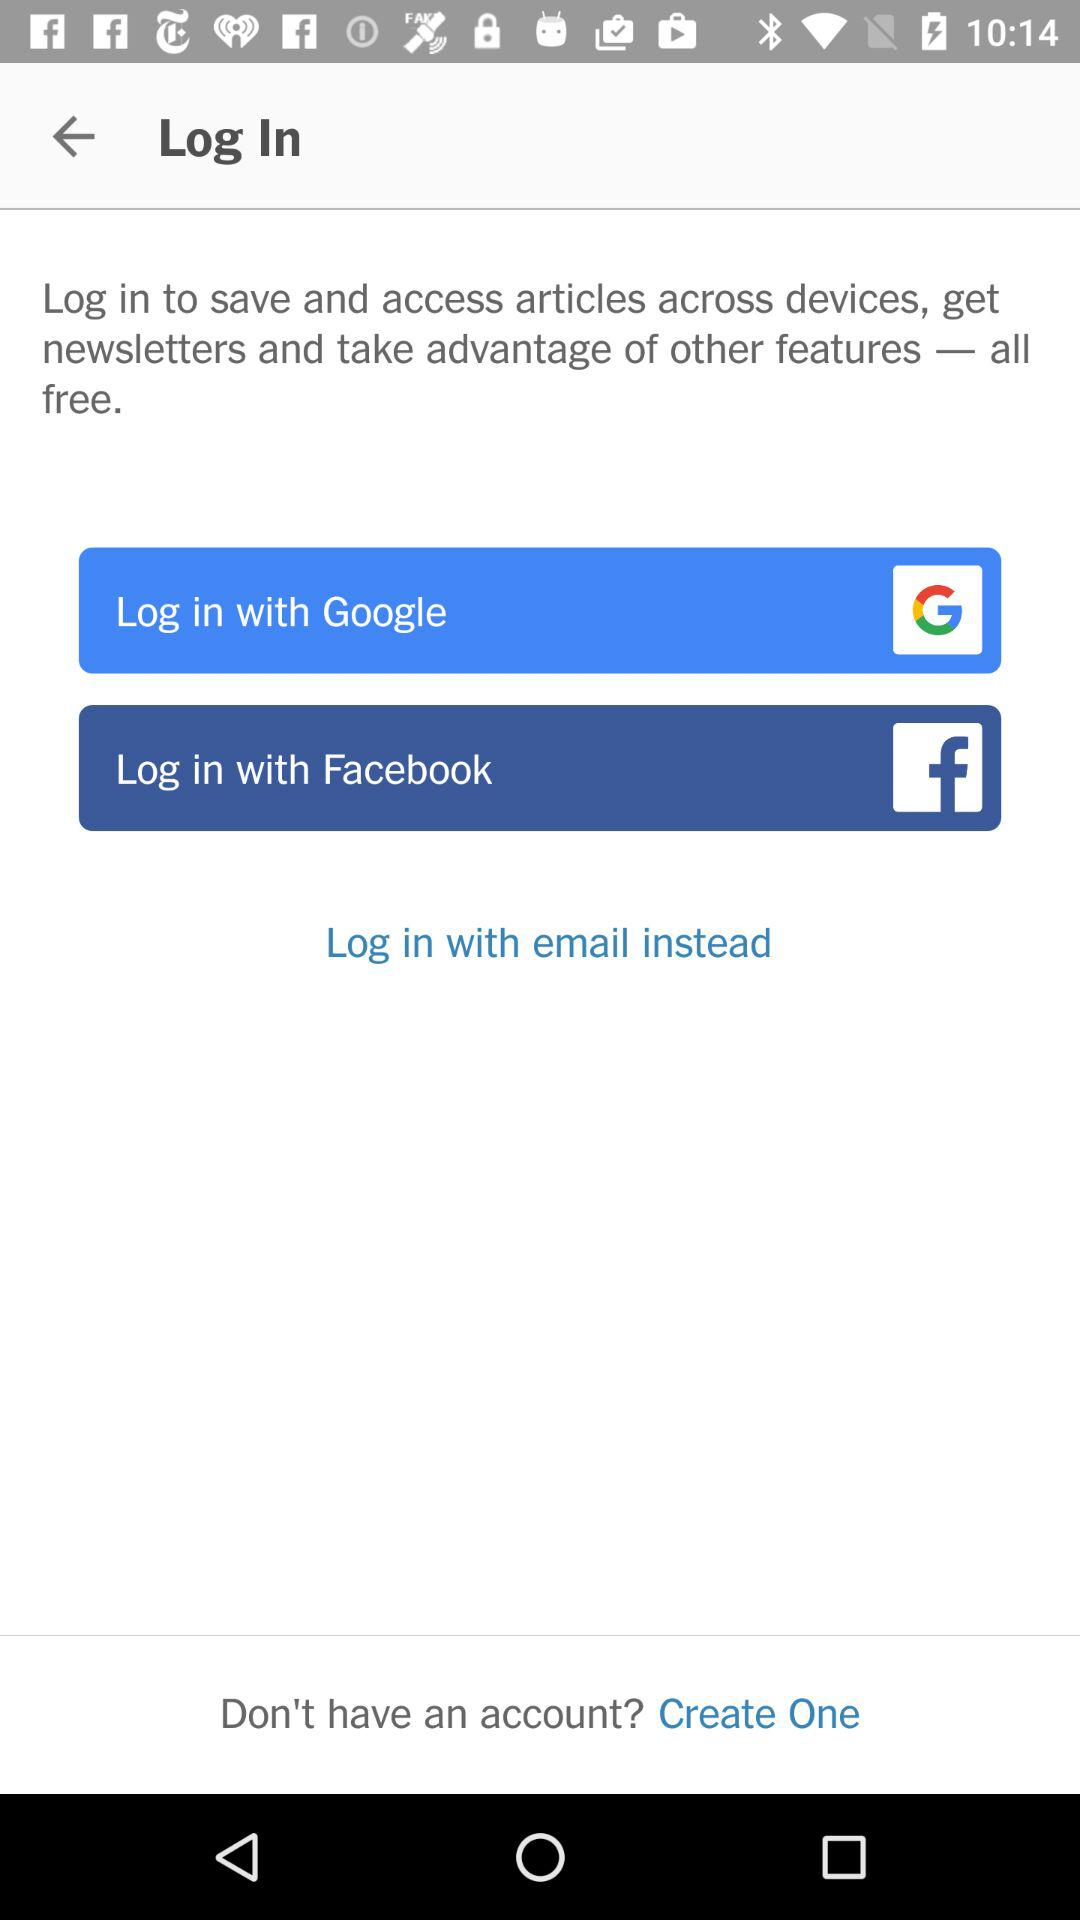How can we log in? You can log in with "Google", "Facebook" and "email". 